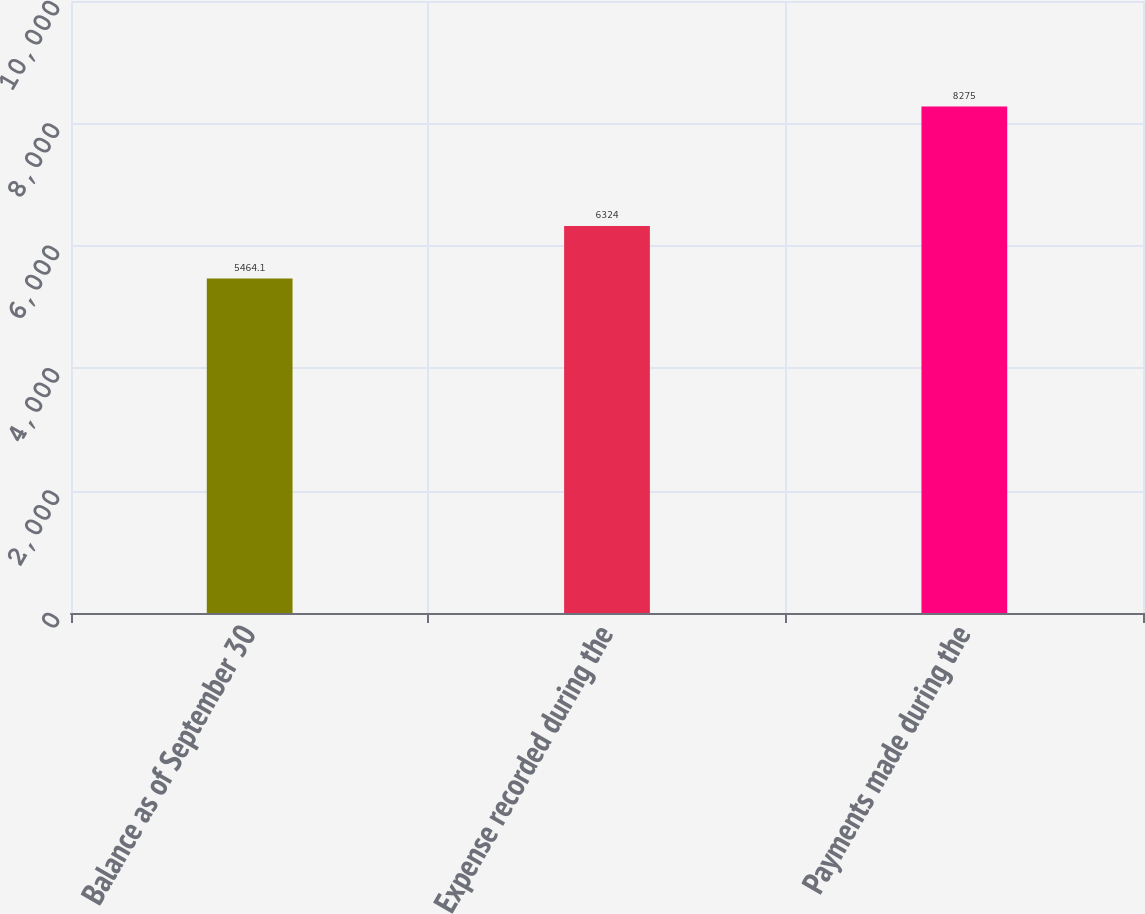<chart> <loc_0><loc_0><loc_500><loc_500><bar_chart><fcel>Balance as of September 30<fcel>Expense recorded during the<fcel>Payments made during the<nl><fcel>5464.1<fcel>6324<fcel>8275<nl></chart> 